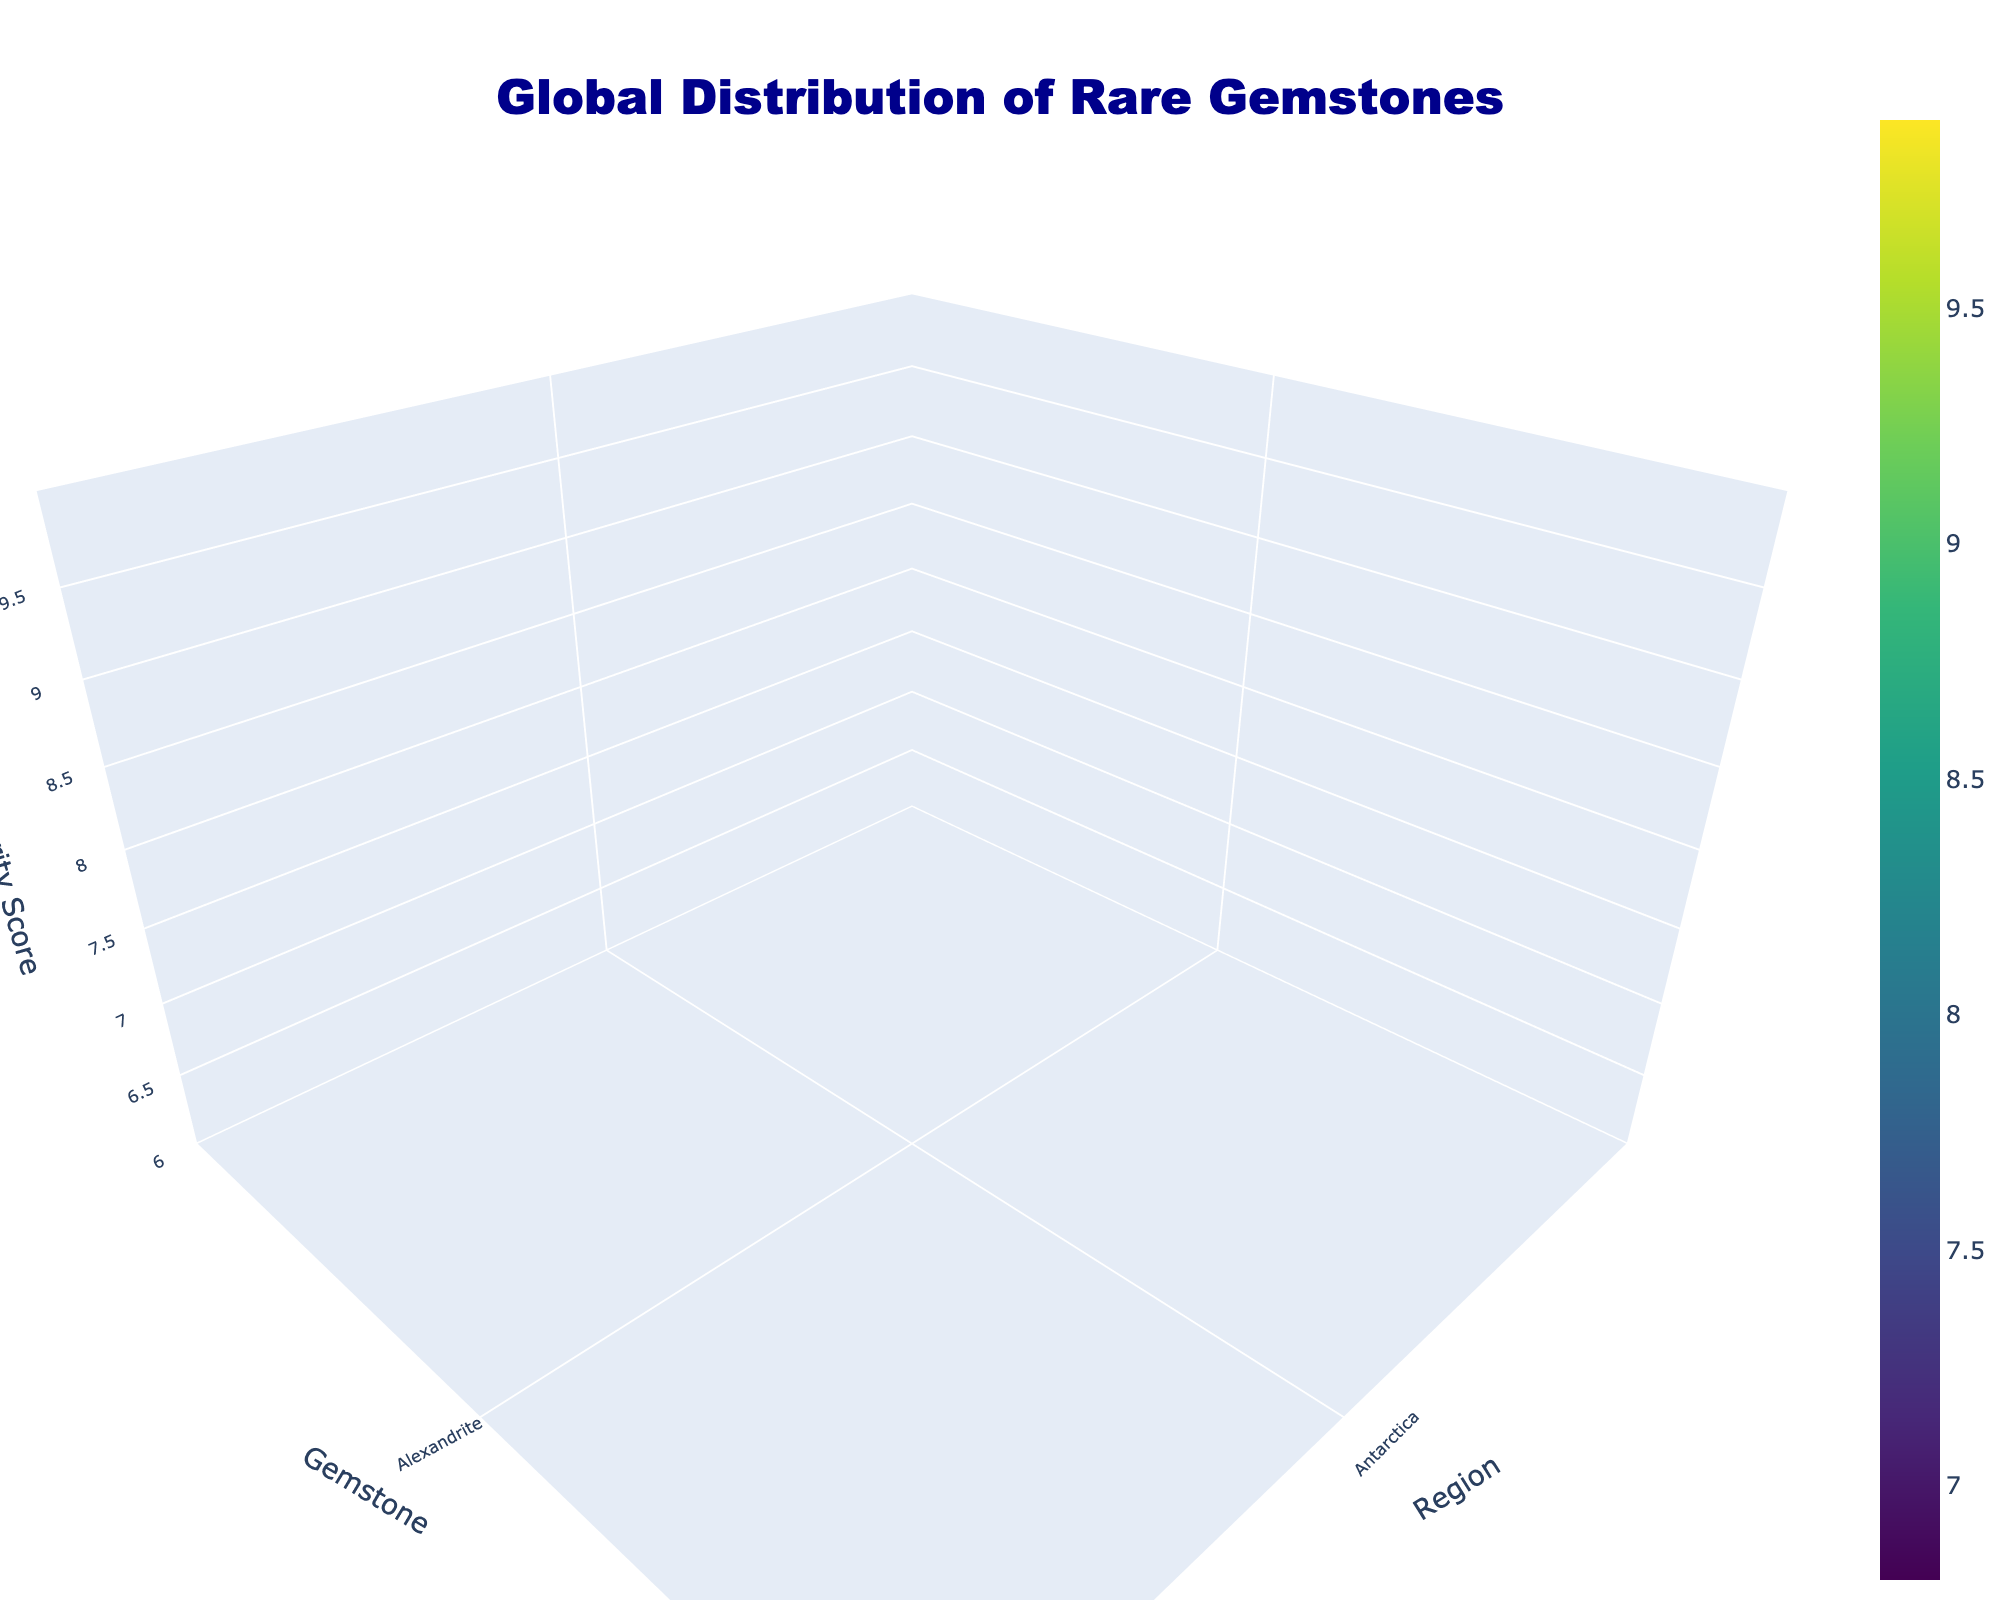What's the title of the 3D surface plot? Look at the top of the plot. The title is typically displayed prominently to describe the subject of the plot.
Answer: Global Distribution of Rare Gemstones Which region has the gemstone with the highest rarity score? Examine the z-axis for the maximum value and see which x-axis region it corresponds to. The highest rarity score is associated with Musgravite in Antarctica.
Answer: Antarctica How many regions are displayed on the x-axis? Count the tick marks or labels along the x-axis, where each tick mark represents a region.
Answer: 19 What is the rarity score of Tanzanite from Tanzania? Find Tanzania on the x-axis, then trace vertically to Tanzanite on the y-axis, and finally check the z-axis value.
Answer: 8.5 Which gemstones from Sri Lanka have the highest rarity scores? Look at the x-axis for Sri Lanka, then trace the corresponding values along the z-axis for the y-axis gemstones from Sri Lanka. Taaffeite and Serendibite have the highest scores.
Answer: Taaffeite and Serendibite What is the average rarity score of the gemstones from Utah? Identify the z-axis values of Red Beryl and Bixbite on the y-axis gemstones corresponding to Utah on the x-axis. Calculate the average (9.4 for Red Beryl and 9.2 for Bixbite). (9.4 + 9.2) / 2 = 9.3
Answer: 9.3 Which gemstone has a higher rarity score, Alexandrite from Russia or Paraiba Tourmaline from Brazil? Compare the z-axis values of Alexandrite at Russia and Paraiba Tourmaline at Brazil. Alexandrite has 9.2 and Paraiba Tourmaline has 9.5.
Answer: Paraiba Tourmaline Are there any gemstones with a rarity score less than 7 from any region? Look for any z-axis values below 7 across all regions. Since no z-axis values fall below 7, all rarity scores are above 7.
Answer: No Which gemstone in Madagascar has the highest rarity score? Identify Madagascar on the x-axis, then trace vertically along the y-axis to see which gemstone from Madagascar has the highest z-axis value. Grandidierite has the highest rarity score.
Answer: Grandidierite What's the range of the z-axis (rarity score) in the plot? Look at the two ends of the z-axis to determine the minimum and maximum values shown. The range for rarity score is from 6 to 10.
Answer: 6 to 10 